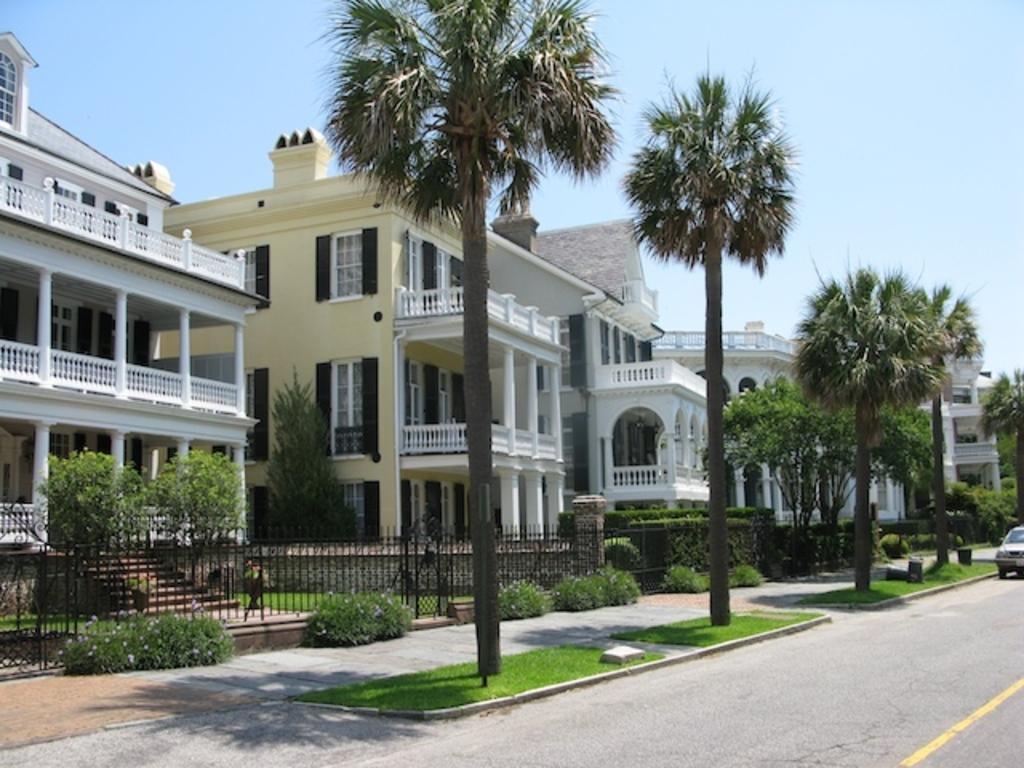Can you describe this image briefly? There are some trees and a car present on the road as we can see at the bottom of this image. There is a fence and some buildings are in the background, and there is a sky at the top of this image. 